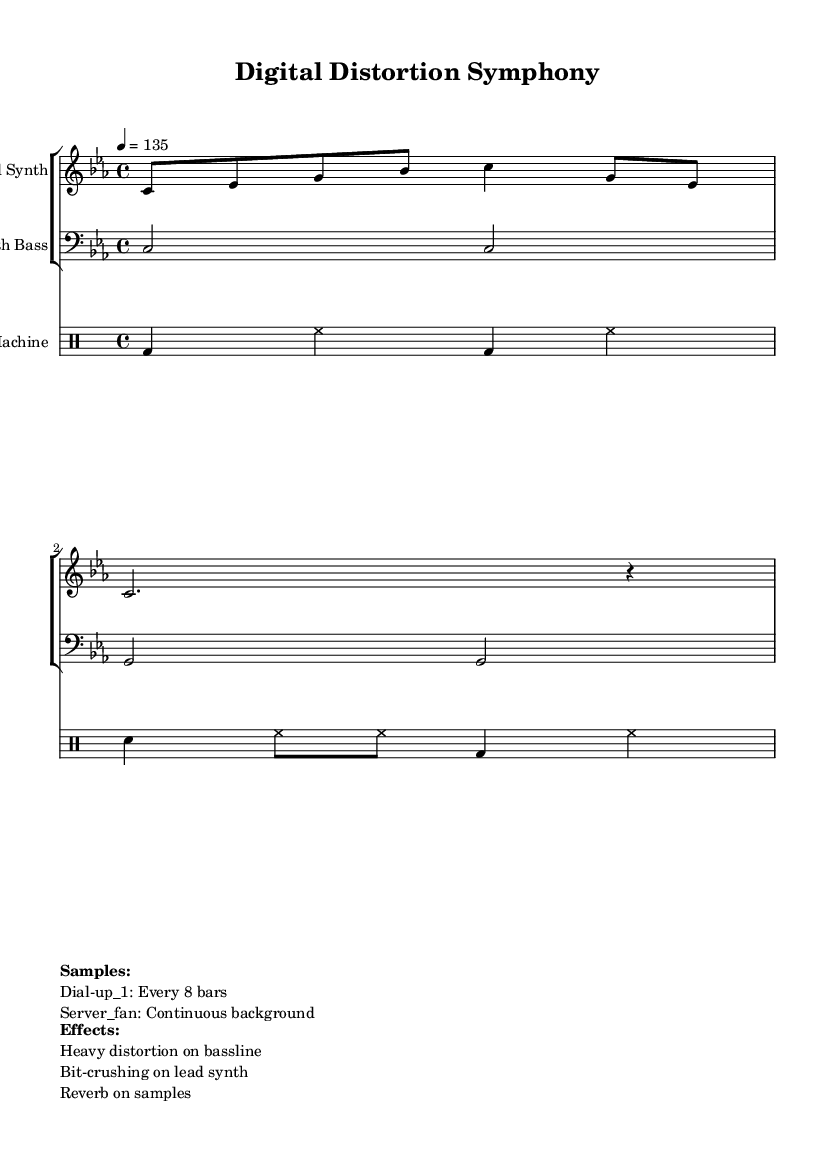What is the key signature of this music? The key signature is C minor, which has three flats (B, E, and A). You can identify the key signature by looking at the beginning of the staff where it indicates the flats or sharps.
Answer: C minor What is the time signature of this music? The time signature is 4/4, shown at the beginning of the score next to the key signature. It indicates four beats per measure, with the quarter note receiving one beat.
Answer: 4/4 What is the tempo marking for this piece? The tempo is indicated as 4 = 135, meaning that the quarter note is to be played at 135 beats per minute. The tempo marking is typically found at the beginning of the score, usually after the key and time signatures.
Answer: 135 How many bars are present in the synth bass part? The synth bass part contains two bars, as indicated by the notation that spans only two measures before concluding. This can be counted from the beginning to the end of the part.
Answer: 2 What type of effect is applied to the lead synth? The lead synth has bit-crushing applied to it, which is a specific effect that distorts the sound by reducing the bit depth, making it gritty and harsh. This information is provided in the markings below the score that describe effects used in the composition.
Answer: Bit-crushing How frequently does the dial-up sample occur in the piece? The dial-up sample occurs every 8 bars, as indicated in the markup section that outlines the samples. This means that for every 8 measures played, the sample will be triggered.
Answer: Every 8 bars What instrument plays the drum patterns in this piece? The drum patterns are played on the drum machine, which is clearly labeled in the score. The instrument name for the drum staff indicates which type of instrument is performing the parts.
Answer: Drum Machine 